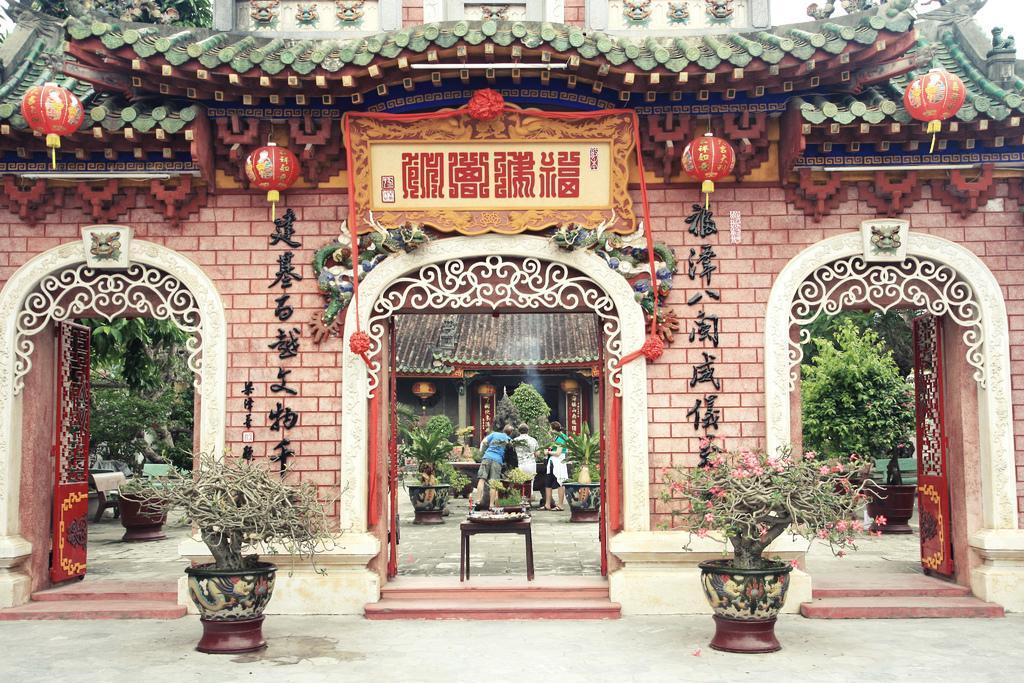Please provide a concise description of this image. In the middle of the image there is a wall, on the wall there are some doors. Behind the wall there are some trees and plants and there is a house. In the middle of the image few people are standing and watching. Bottom of the image there are some plants and flowers. 